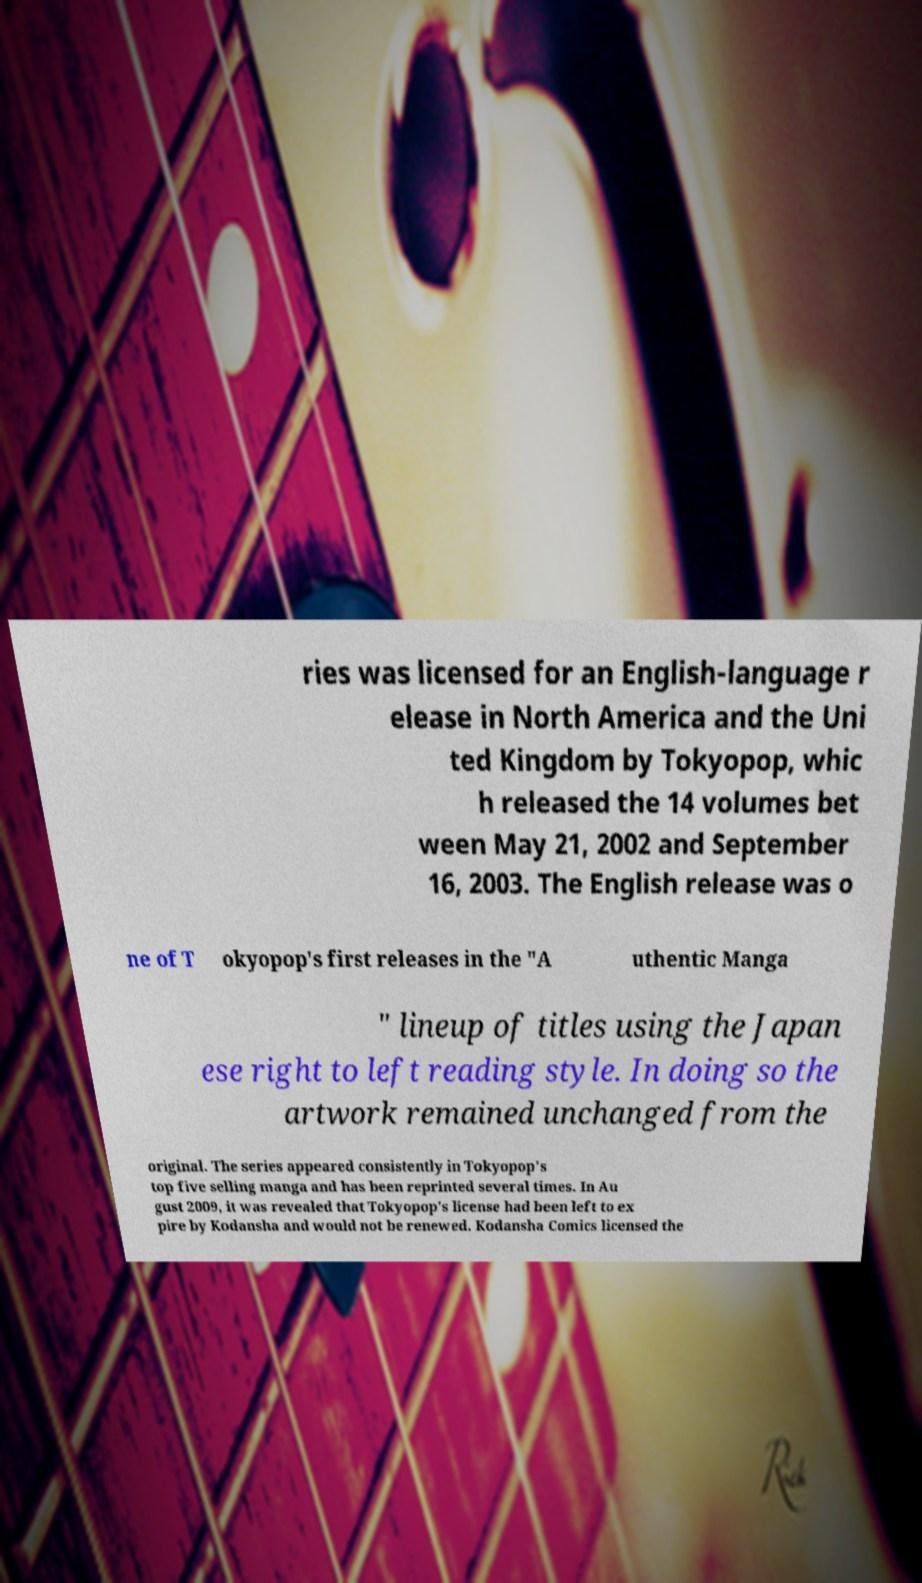I need the written content from this picture converted into text. Can you do that? ries was licensed for an English-language r elease in North America and the Uni ted Kingdom by Tokyopop, whic h released the 14 volumes bet ween May 21, 2002 and September 16, 2003. The English release was o ne of T okyopop's first releases in the "A uthentic Manga " lineup of titles using the Japan ese right to left reading style. In doing so the artwork remained unchanged from the original. The series appeared consistently in Tokyopop's top five selling manga and has been reprinted several times. In Au gust 2009, it was revealed that Tokyopop's license had been left to ex pire by Kodansha and would not be renewed. Kodansha Comics licensed the 